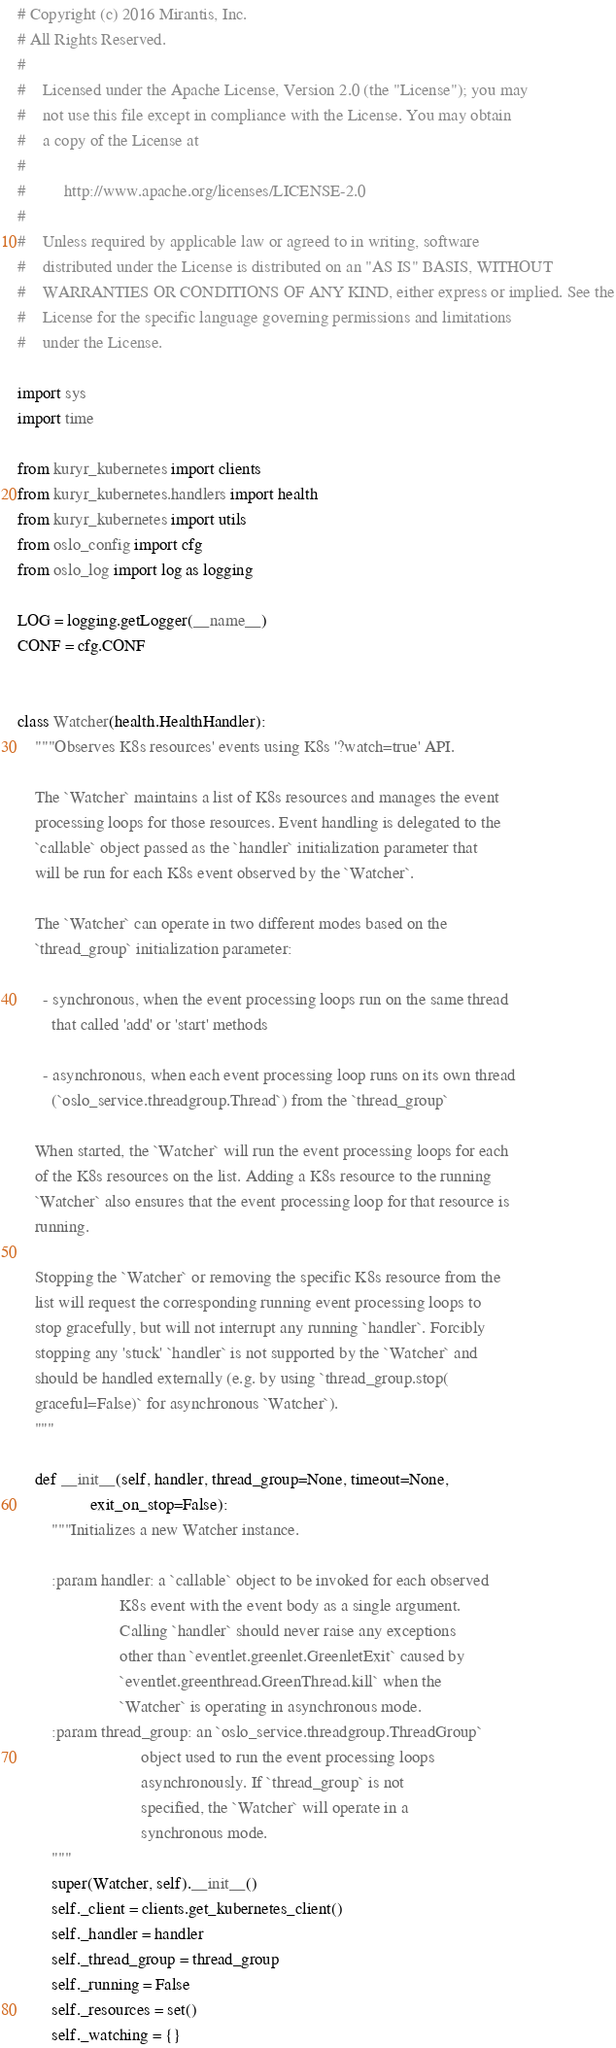<code> <loc_0><loc_0><loc_500><loc_500><_Python_># Copyright (c) 2016 Mirantis, Inc.
# All Rights Reserved.
#
#    Licensed under the Apache License, Version 2.0 (the "License"); you may
#    not use this file except in compliance with the License. You may obtain
#    a copy of the License at
#
#         http://www.apache.org/licenses/LICENSE-2.0
#
#    Unless required by applicable law or agreed to in writing, software
#    distributed under the License is distributed on an "AS IS" BASIS, WITHOUT
#    WARRANTIES OR CONDITIONS OF ANY KIND, either express or implied. See the
#    License for the specific language governing permissions and limitations
#    under the License.

import sys
import time

from kuryr_kubernetes import clients
from kuryr_kubernetes.handlers import health
from kuryr_kubernetes import utils
from oslo_config import cfg
from oslo_log import log as logging

LOG = logging.getLogger(__name__)
CONF = cfg.CONF


class Watcher(health.HealthHandler):
    """Observes K8s resources' events using K8s '?watch=true' API.

    The `Watcher` maintains a list of K8s resources and manages the event
    processing loops for those resources. Event handling is delegated to the
    `callable` object passed as the `handler` initialization parameter that
    will be run for each K8s event observed by the `Watcher`.

    The `Watcher` can operate in two different modes based on the
    `thread_group` initialization parameter:

      - synchronous, when the event processing loops run on the same thread
        that called 'add' or 'start' methods

      - asynchronous, when each event processing loop runs on its own thread
        (`oslo_service.threadgroup.Thread`) from the `thread_group`

    When started, the `Watcher` will run the event processing loops for each
    of the K8s resources on the list. Adding a K8s resource to the running
    `Watcher` also ensures that the event processing loop for that resource is
    running.

    Stopping the `Watcher` or removing the specific K8s resource from the
    list will request the corresponding running event processing loops to
    stop gracefully, but will not interrupt any running `handler`. Forcibly
    stopping any 'stuck' `handler` is not supported by the `Watcher` and
    should be handled externally (e.g. by using `thread_group.stop(
    graceful=False)` for asynchronous `Watcher`).
    """

    def __init__(self, handler, thread_group=None, timeout=None,
                 exit_on_stop=False):
        """Initializes a new Watcher instance.

        :param handler: a `callable` object to be invoked for each observed
                        K8s event with the event body as a single argument.
                        Calling `handler` should never raise any exceptions
                        other than `eventlet.greenlet.GreenletExit` caused by
                        `eventlet.greenthread.GreenThread.kill` when the
                        `Watcher` is operating in asynchronous mode.
        :param thread_group: an `oslo_service.threadgroup.ThreadGroup`
                             object used to run the event processing loops
                             asynchronously. If `thread_group` is not
                             specified, the `Watcher` will operate in a
                             synchronous mode.
        """
        super(Watcher, self).__init__()
        self._client = clients.get_kubernetes_client()
        self._handler = handler
        self._thread_group = thread_group
        self._running = False
        self._resources = set()
        self._watching = {}</code> 